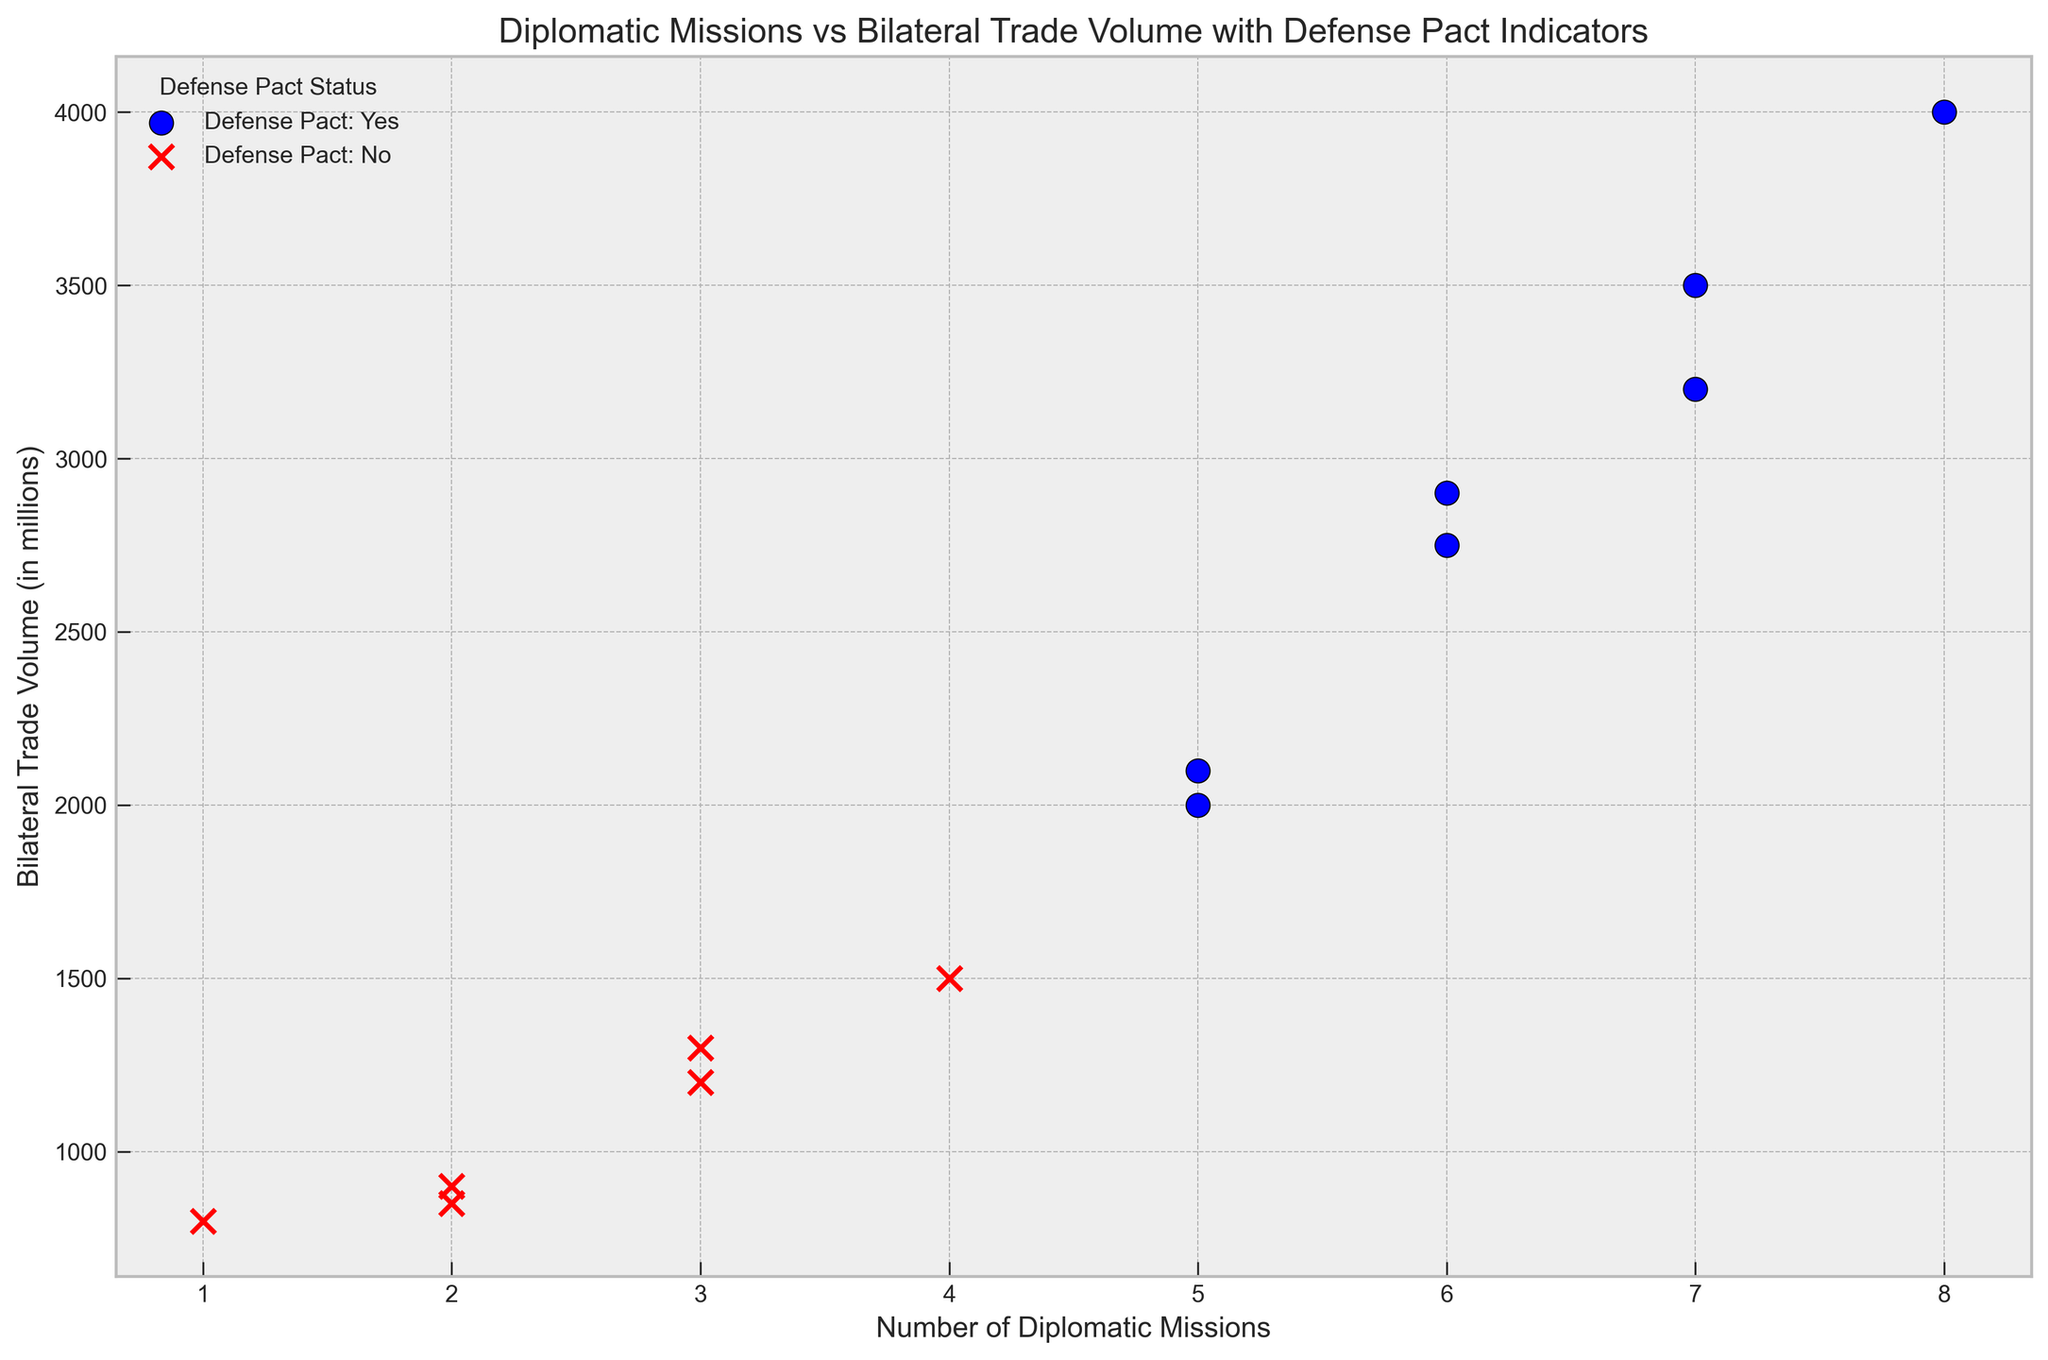Which defense pact status has the highest bilateral trade volume for a country pair? To answer this, observe the highest point on the vertical axis (trade volume) and look at the color/marker type indicating the defense pact status. The highest trade volume is 4000, which corresponds to a blue circle, indicating it has a defense pact.
Answer: Defense pact: Yes How many more diplomatic missions are there on average for countries with defense pacts compared to those without? Calculate the average number of diplomatic missions for countries with and without defense pacts, then find the difference. For "Yes": (5+7+6+8+5+7+6)/7 = 6.29, and for "No": (3+2+4+1+2+3)/6 = 2.5. The difference is 6.29 - 2.5 ≈ 3.79.
Answer: Approximately 3.79 Which data point represents the lowest trade volume and what is its corresponding number of diplomatic missions and defense pact status? Find the lowest point on the vertical axis (trade volume) and check its horizontal position (diplomatic missions) and marker color/type for defense pact status. The lowest trade volume is 800, corresponding to 1 diplomatic mission and a red 'x', indicating no defense pact.
Answer: 1 diplomatic mission, No defense pact Is the average trade volume higher for countries with defense pacts or without? Calculate the average trade volume for countries with and without defense pacts. For "Yes": (2000+3200+2750+4000+2100+3500+2900)/7 = 2921.43, and for "No": (1200+900+1500+800+850+1300)/6 = 925. The average trade volume is higher for countries with defense pacts.
Answer: Higher for countries with defense pacts How does the distribution of trade volumes differ between countries with and without defense pacts? Observe the spread and clustering of data points vertically for both corresponding colors/markers. Countries with defense pacts (blue circles) have trade volumes clustered at higher values (2000 to 4000) compared to those without (red crosses), which are clustered at lower values (800 to 1500).
Answer: Trade volumes are higher and more spread for countries with defense pacts 